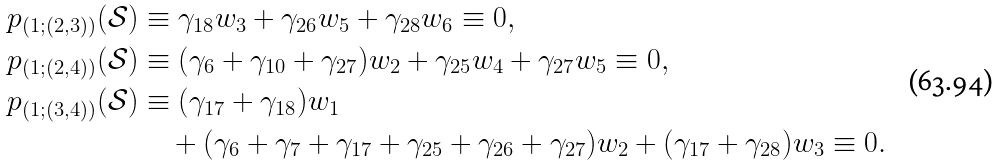Convert formula to latex. <formula><loc_0><loc_0><loc_500><loc_500>p _ { ( 1 ; ( 2 , 3 ) ) } ( \mathcal { S } ) & \equiv \gamma _ { 1 8 } w _ { 3 } + \gamma _ { 2 6 } w _ { 5 } + \gamma _ { 2 8 } w _ { 6 } \equiv 0 , \\ p _ { ( 1 ; ( 2 , 4 ) ) } ( \mathcal { S } ) & \equiv ( \gamma _ { 6 } + \gamma _ { 1 0 } + \gamma _ { 2 7 } ) w _ { 2 } + \gamma _ { 2 5 } w _ { 4 } + \gamma _ { 2 7 } w _ { 5 } \equiv 0 , \\ p _ { ( 1 ; ( 3 , 4 ) ) } ( \mathcal { S } ) & \equiv ( \gamma _ { 1 7 } + \gamma _ { 1 8 } ) w _ { 1 } \\ & \quad + ( \gamma _ { 6 } + \gamma _ { 7 } + \gamma _ { 1 7 } + \gamma _ { 2 5 } + \gamma _ { 2 6 } + \gamma _ { 2 7 } ) w _ { 2 } + ( \gamma _ { 1 7 } + \gamma _ { 2 8 } ) w _ { 3 } \equiv 0 .</formula> 